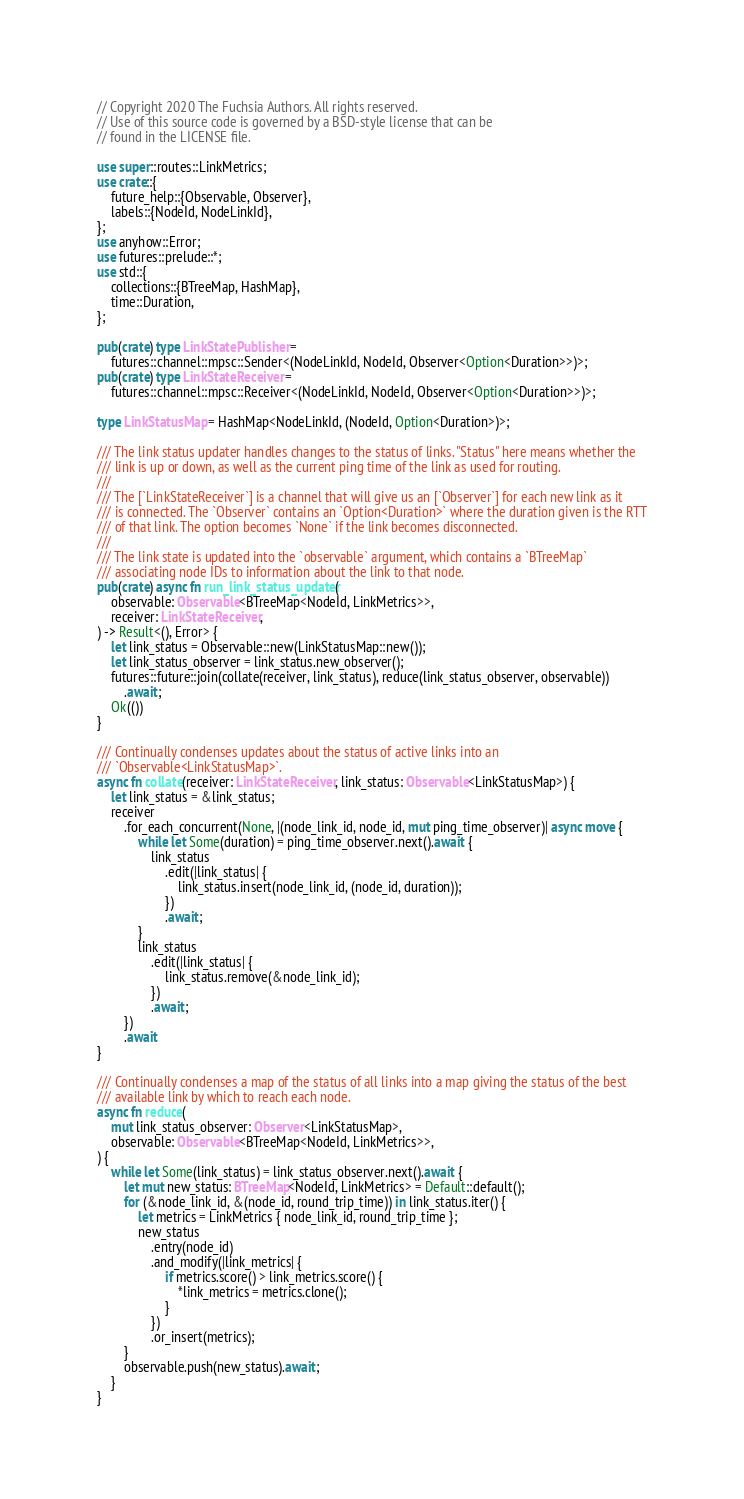Convert code to text. <code><loc_0><loc_0><loc_500><loc_500><_Rust_>// Copyright 2020 The Fuchsia Authors. All rights reserved.
// Use of this source code is governed by a BSD-style license that can be
// found in the LICENSE file.

use super::routes::LinkMetrics;
use crate::{
    future_help::{Observable, Observer},
    labels::{NodeId, NodeLinkId},
};
use anyhow::Error;
use futures::prelude::*;
use std::{
    collections::{BTreeMap, HashMap},
    time::Duration,
};

pub(crate) type LinkStatePublisher =
    futures::channel::mpsc::Sender<(NodeLinkId, NodeId, Observer<Option<Duration>>)>;
pub(crate) type LinkStateReceiver =
    futures::channel::mpsc::Receiver<(NodeLinkId, NodeId, Observer<Option<Duration>>)>;

type LinkStatusMap = HashMap<NodeLinkId, (NodeId, Option<Duration>)>;

/// The link status updater handles changes to the status of links. "Status" here means whether the
/// link is up or down, as well as the current ping time of the link as used for routing.
///
/// The [`LinkStateReceiver`] is a channel that will give us an [`Observer`] for each new link as it
/// is connected. The `Observer` contains an `Option<Duration>` where the duration given is the RTT
/// of that link. The option becomes `None` if the link becomes disconnected.
///
/// The link state is updated into the `observable` argument, which contains a `BTreeMap`
/// associating node IDs to information about the link to that node.
pub(crate) async fn run_link_status_updater(
    observable: Observable<BTreeMap<NodeId, LinkMetrics>>,
    receiver: LinkStateReceiver,
) -> Result<(), Error> {
    let link_status = Observable::new(LinkStatusMap::new());
    let link_status_observer = link_status.new_observer();
    futures::future::join(collate(receiver, link_status), reduce(link_status_observer, observable))
        .await;
    Ok(())
}

/// Continually condenses updates about the status of active links into an
/// `Observable<LinkStatusMap>`.
async fn collate(receiver: LinkStateReceiver, link_status: Observable<LinkStatusMap>) {
    let link_status = &link_status;
    receiver
        .for_each_concurrent(None, |(node_link_id, node_id, mut ping_time_observer)| async move {
            while let Some(duration) = ping_time_observer.next().await {
                link_status
                    .edit(|link_status| {
                        link_status.insert(node_link_id, (node_id, duration));
                    })
                    .await;
            }
            link_status
                .edit(|link_status| {
                    link_status.remove(&node_link_id);
                })
                .await;
        })
        .await
}

/// Continually condenses a map of the status of all links into a map giving the status of the best
/// available link by which to reach each node.
async fn reduce(
    mut link_status_observer: Observer<LinkStatusMap>,
    observable: Observable<BTreeMap<NodeId, LinkMetrics>>,
) {
    while let Some(link_status) = link_status_observer.next().await {
        let mut new_status: BTreeMap<NodeId, LinkMetrics> = Default::default();
        for (&node_link_id, &(node_id, round_trip_time)) in link_status.iter() {
            let metrics = LinkMetrics { node_link_id, round_trip_time };
            new_status
                .entry(node_id)
                .and_modify(|link_metrics| {
                    if metrics.score() > link_metrics.score() {
                        *link_metrics = metrics.clone();
                    }
                })
                .or_insert(metrics);
        }
        observable.push(new_status).await;
    }
}
</code> 